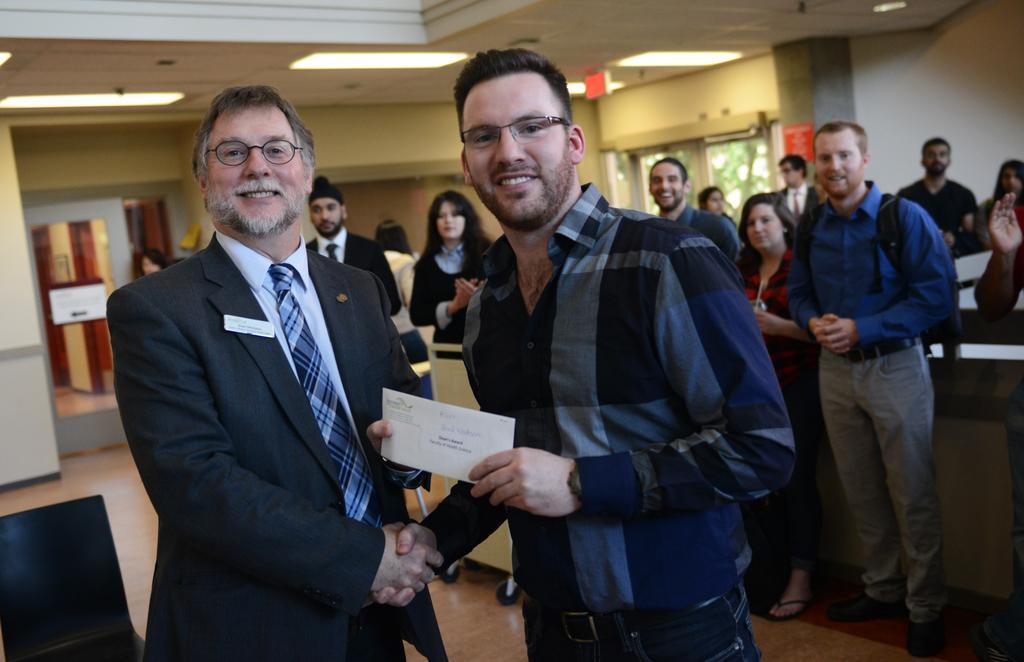Can you describe this image briefly? Here in the front we can see two persons standing on the floor and the person on the left side is wearing a coat and tie on him and he is handing a card to the person beside him and he is shaking hands with him and both of them are smiling and wearing spectacles on them and behind them also we can see number of people standing all over the place over there and we can see lights on the roof present over there. 